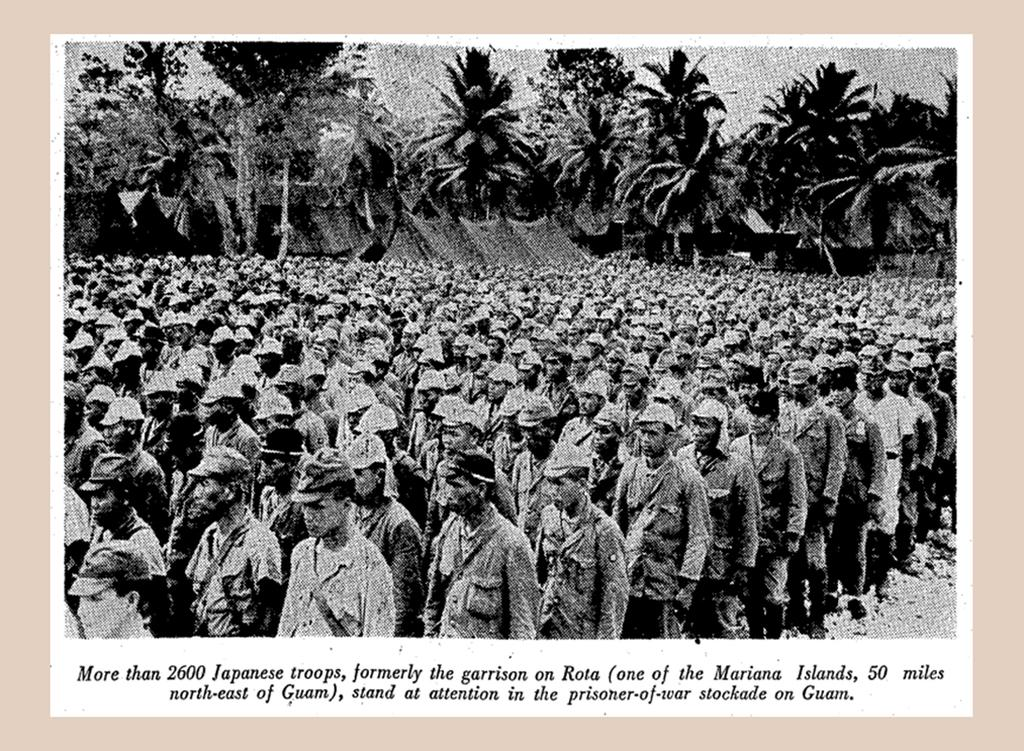<image>
Summarize the visual content of the image. A caption under an old photograph is about Japanese troops in a prison yard on Guam. 